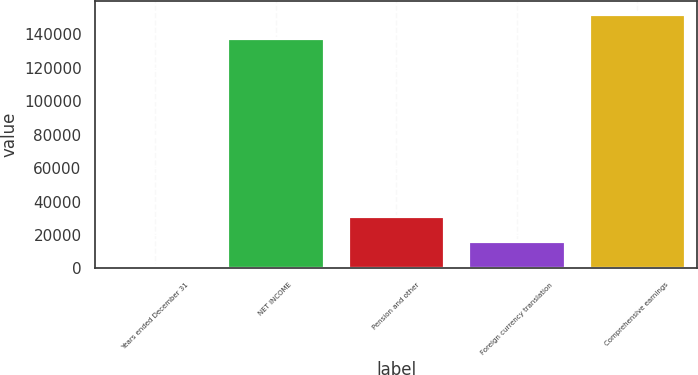Convert chart to OTSL. <chart><loc_0><loc_0><loc_500><loc_500><bar_chart><fcel>Years ended December 31<fcel>NET INCOME<fcel>Pension and other<fcel>Foreign currency translation<fcel>Comprehensive earnings<nl><fcel>2014<fcel>137664<fcel>31316.4<fcel>16665.2<fcel>152315<nl></chart> 